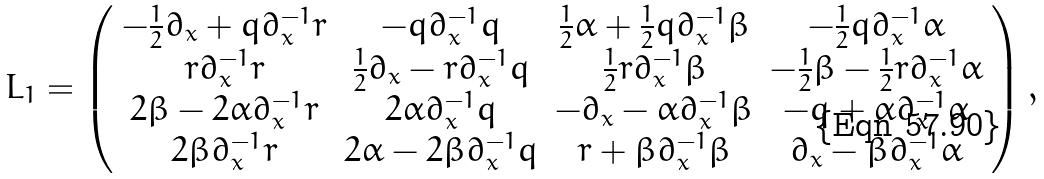Convert formula to latex. <formula><loc_0><loc_0><loc_500><loc_500>L _ { 1 } = \left ( \begin{array} { c c c c } - \frac { 1 } { 2 } \partial _ { x } + q \partial _ { x } ^ { - 1 } r & - q \partial _ { x } ^ { - 1 } q & \frac { 1 } { 2 } \alpha + \frac { 1 } { 2 } q \partial _ { x } ^ { - 1 } \beta & - \frac { 1 } { 2 } q \partial _ { x } ^ { - 1 } \alpha \\ r \partial _ { x } ^ { - 1 } r & \frac { 1 } { 2 } \partial _ { x } - r \partial _ { x } ^ { - 1 } q & \frac { 1 } { 2 } r \partial _ { x } ^ { - 1 } \beta & - \frac { 1 } { 2 } \beta - \frac { 1 } { 2 } r \partial _ { x } ^ { - 1 } \alpha \\ 2 \beta - 2 \alpha \partial _ { x } ^ { - 1 } r & 2 \alpha \partial _ { x } ^ { - 1 } q & - \partial _ { x } - \alpha \partial _ { x } ^ { - 1 } \beta & - q + \alpha \partial _ { x } ^ { - 1 } \alpha \\ 2 \beta \partial _ { x } ^ { - 1 } r & 2 \alpha - 2 \beta \partial _ { x } ^ { - 1 } q & r + \beta \partial _ { x } ^ { - 1 } \beta & \partial _ { x } - \beta \partial _ { x } ^ { - 1 } \alpha \end{array} \right ) ,</formula> 